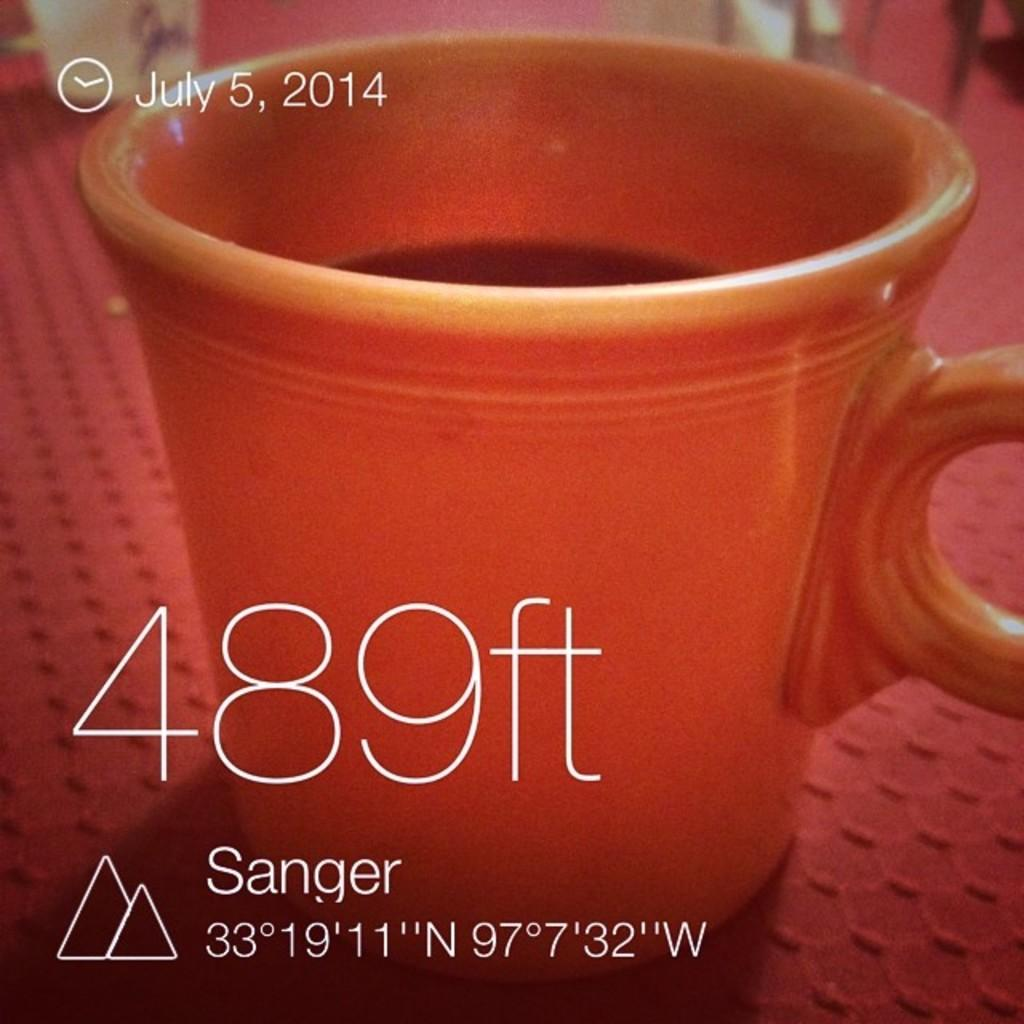What is in the image that people typically drink from? There is a coffee cup in the image. What color is the coffee cup? The coffee cup is red. Where is the coffee cup located in the image? The coffee cup is on a table. What is covering the table in the image? The table is covered with a red cloth. What type of information can be found in the image? There is text in the image. Is there any specific date mentioned in the image? Yes, there is a date in the top left corner of the image. Is there a tiger sitting next to the coffee cup in the image? No, there is no tiger present in the image. 